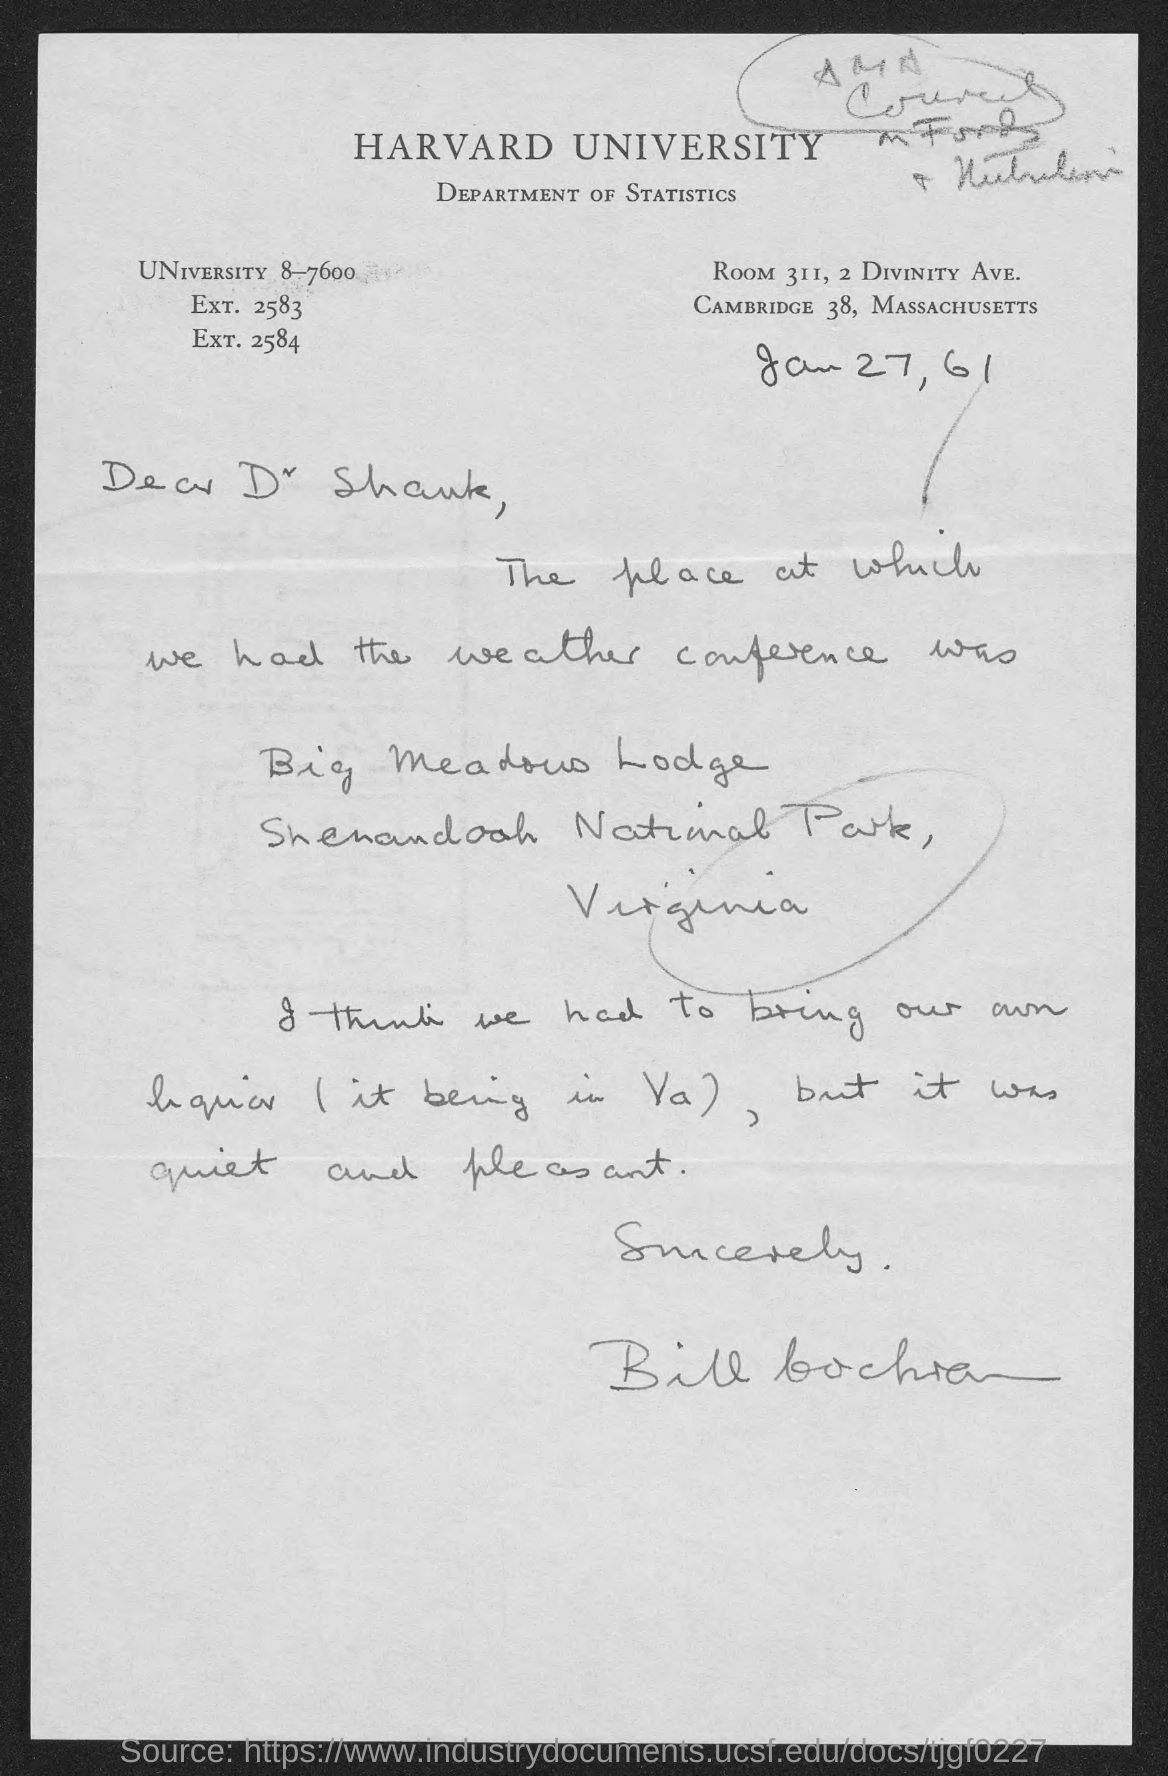What is the name of the university mentioned at top of page?
Ensure brevity in your answer.  HARVARD UNIVERSITY. What is the room number of department of statistics ?
Make the answer very short. 311. To whom this letter is written to?
Provide a short and direct response. Dr Shank. The letter is dated on?
Ensure brevity in your answer.  Jan 27, 61. 